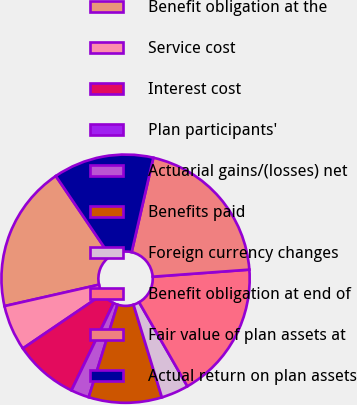Convert chart. <chart><loc_0><loc_0><loc_500><loc_500><pie_chart><fcel>Benefit obligation at the<fcel>Service cost<fcel>Interest cost<fcel>Plan participants'<fcel>Actuarial gains/(losses) net<fcel>Benefits paid<fcel>Foreign currency changes<fcel>Benefit obligation at end of<fcel>Fair value of plan assets at<fcel>Actual return on plan assets<nl><fcel>19.05%<fcel>5.95%<fcel>8.33%<fcel>0.0%<fcel>2.38%<fcel>9.52%<fcel>3.57%<fcel>17.86%<fcel>20.24%<fcel>13.09%<nl></chart> 